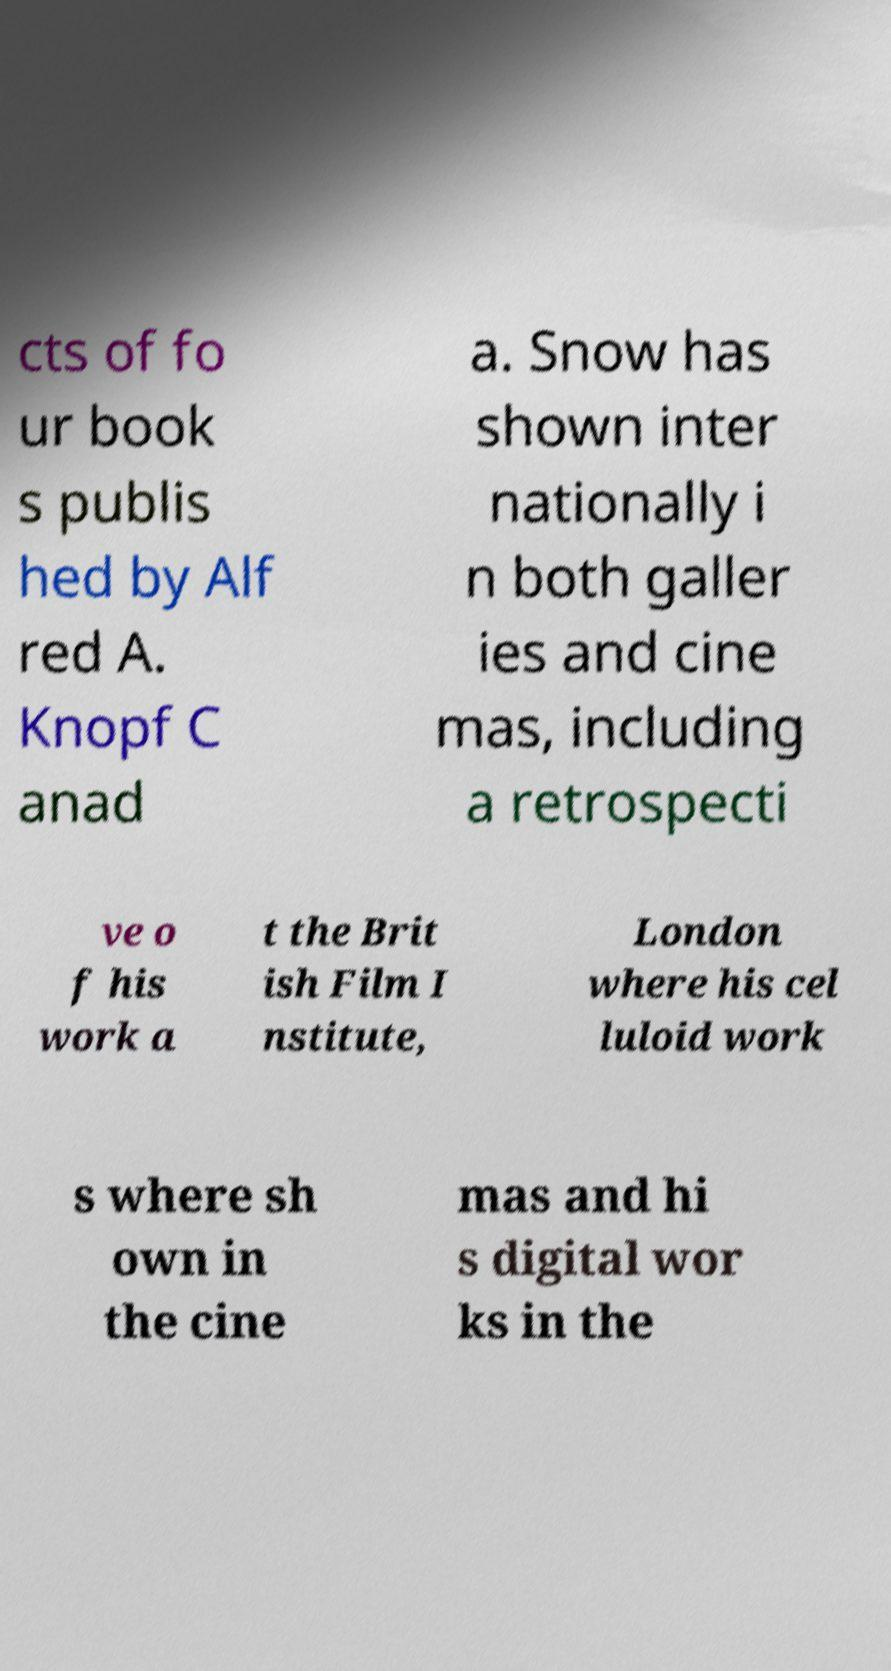Could you extract and type out the text from this image? cts of fo ur book s publis hed by Alf red A. Knopf C anad a. Snow has shown inter nationally i n both galler ies and cine mas, including a retrospecti ve o f his work a t the Brit ish Film I nstitute, London where his cel luloid work s where sh own in the cine mas and hi s digital wor ks in the 